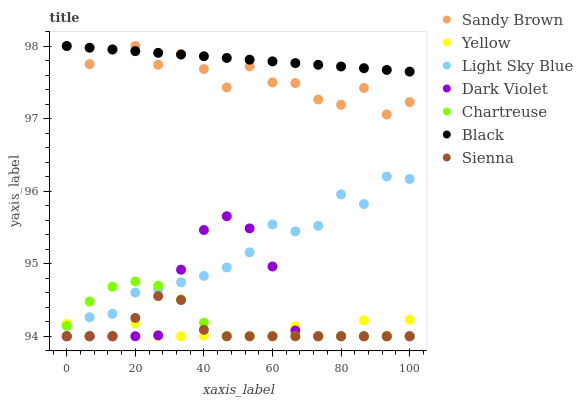Does Yellow have the minimum area under the curve?
Answer yes or no. Yes. Does Black have the maximum area under the curve?
Answer yes or no. Yes. Does Sienna have the minimum area under the curve?
Answer yes or no. No. Does Sienna have the maximum area under the curve?
Answer yes or no. No. Is Black the smoothest?
Answer yes or no. Yes. Is Sandy Brown the roughest?
Answer yes or no. Yes. Is Sienna the smoothest?
Answer yes or no. No. Is Sienna the roughest?
Answer yes or no. No. Does Dark Violet have the lowest value?
Answer yes or no. Yes. Does Black have the lowest value?
Answer yes or no. No. Does Sandy Brown have the highest value?
Answer yes or no. Yes. Does Sienna have the highest value?
Answer yes or no. No. Is Chartreuse less than Black?
Answer yes or no. Yes. Is Sandy Brown greater than Dark Violet?
Answer yes or no. Yes. Does Dark Violet intersect Chartreuse?
Answer yes or no. Yes. Is Dark Violet less than Chartreuse?
Answer yes or no. No. Is Dark Violet greater than Chartreuse?
Answer yes or no. No. Does Chartreuse intersect Black?
Answer yes or no. No. 